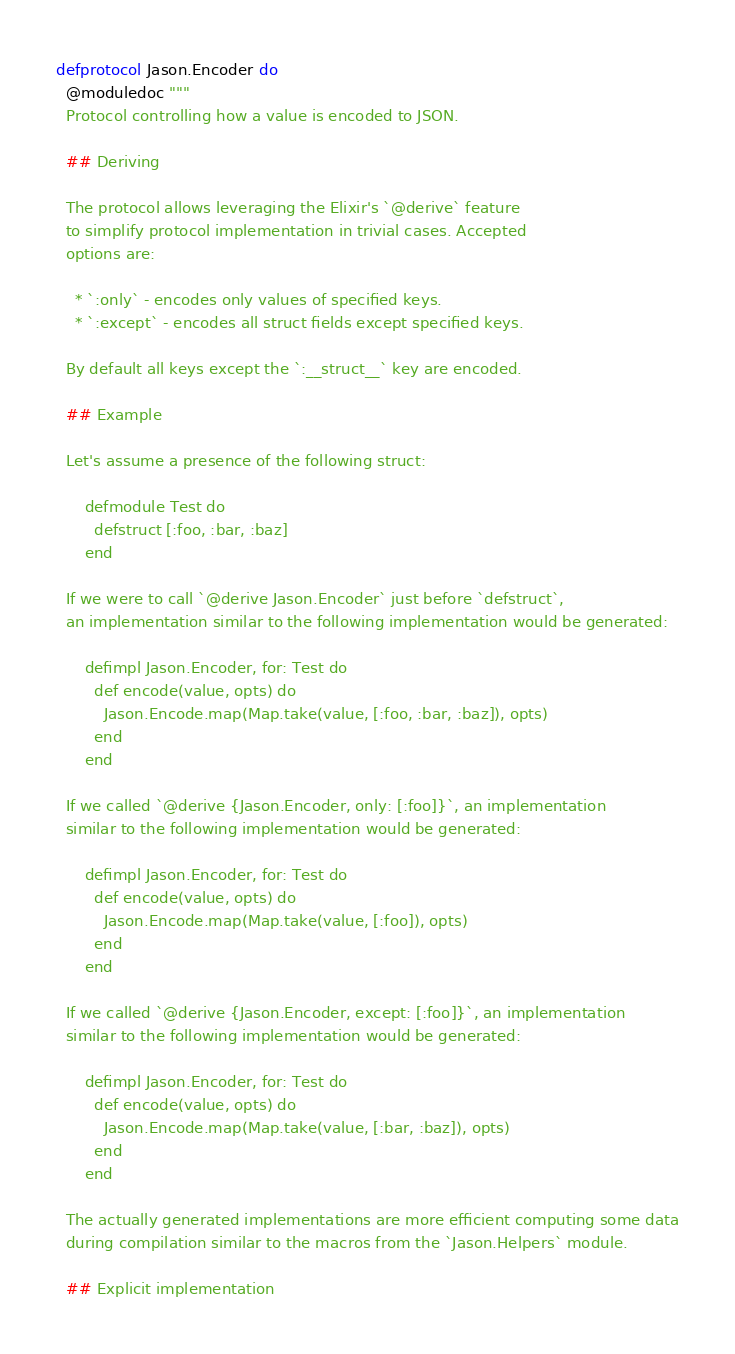<code> <loc_0><loc_0><loc_500><loc_500><_Elixir_>defprotocol Jason.Encoder do
  @moduledoc """
  Protocol controlling how a value is encoded to JSON.

  ## Deriving

  The protocol allows leveraging the Elixir's `@derive` feature
  to simplify protocol implementation in trivial cases. Accepted
  options are:

    * `:only` - encodes only values of specified keys.
    * `:except` - encodes all struct fields except specified keys.

  By default all keys except the `:__struct__` key are encoded.

  ## Example

  Let's assume a presence of the following struct:

      defmodule Test do
        defstruct [:foo, :bar, :baz]
      end

  If we were to call `@derive Jason.Encoder` just before `defstruct`,
  an implementation similar to the following implementation would be generated:

      defimpl Jason.Encoder, for: Test do
        def encode(value, opts) do
          Jason.Encode.map(Map.take(value, [:foo, :bar, :baz]), opts)
        end
      end

  If we called `@derive {Jason.Encoder, only: [:foo]}`, an implementation
  similar to the following implementation would be generated:

      defimpl Jason.Encoder, for: Test do
        def encode(value, opts) do
          Jason.Encode.map(Map.take(value, [:foo]), opts)
        end
      end

  If we called `@derive {Jason.Encoder, except: [:foo]}`, an implementation
  similar to the following implementation would be generated:

      defimpl Jason.Encoder, for: Test do
        def encode(value, opts) do
          Jason.Encode.map(Map.take(value, [:bar, :baz]), opts)
        end
      end

  The actually generated implementations are more efficient computing some data
  during compilation similar to the macros from the `Jason.Helpers` module.

  ## Explicit implementation
</code> 